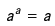Convert formula to latex. <formula><loc_0><loc_0><loc_500><loc_500>a ^ { a } = a</formula> 